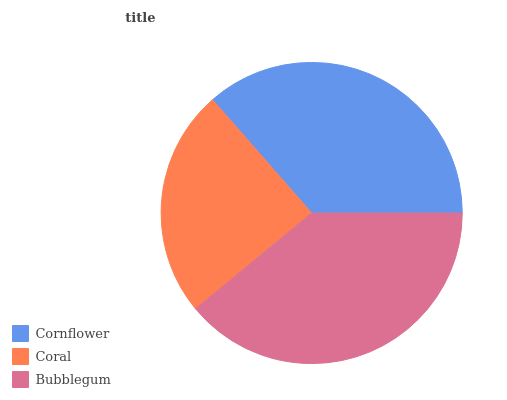Is Coral the minimum?
Answer yes or no. Yes. Is Bubblegum the maximum?
Answer yes or no. Yes. Is Bubblegum the minimum?
Answer yes or no. No. Is Coral the maximum?
Answer yes or no. No. Is Bubblegum greater than Coral?
Answer yes or no. Yes. Is Coral less than Bubblegum?
Answer yes or no. Yes. Is Coral greater than Bubblegum?
Answer yes or no. No. Is Bubblegum less than Coral?
Answer yes or no. No. Is Cornflower the high median?
Answer yes or no. Yes. Is Cornflower the low median?
Answer yes or no. Yes. Is Bubblegum the high median?
Answer yes or no. No. Is Bubblegum the low median?
Answer yes or no. No. 